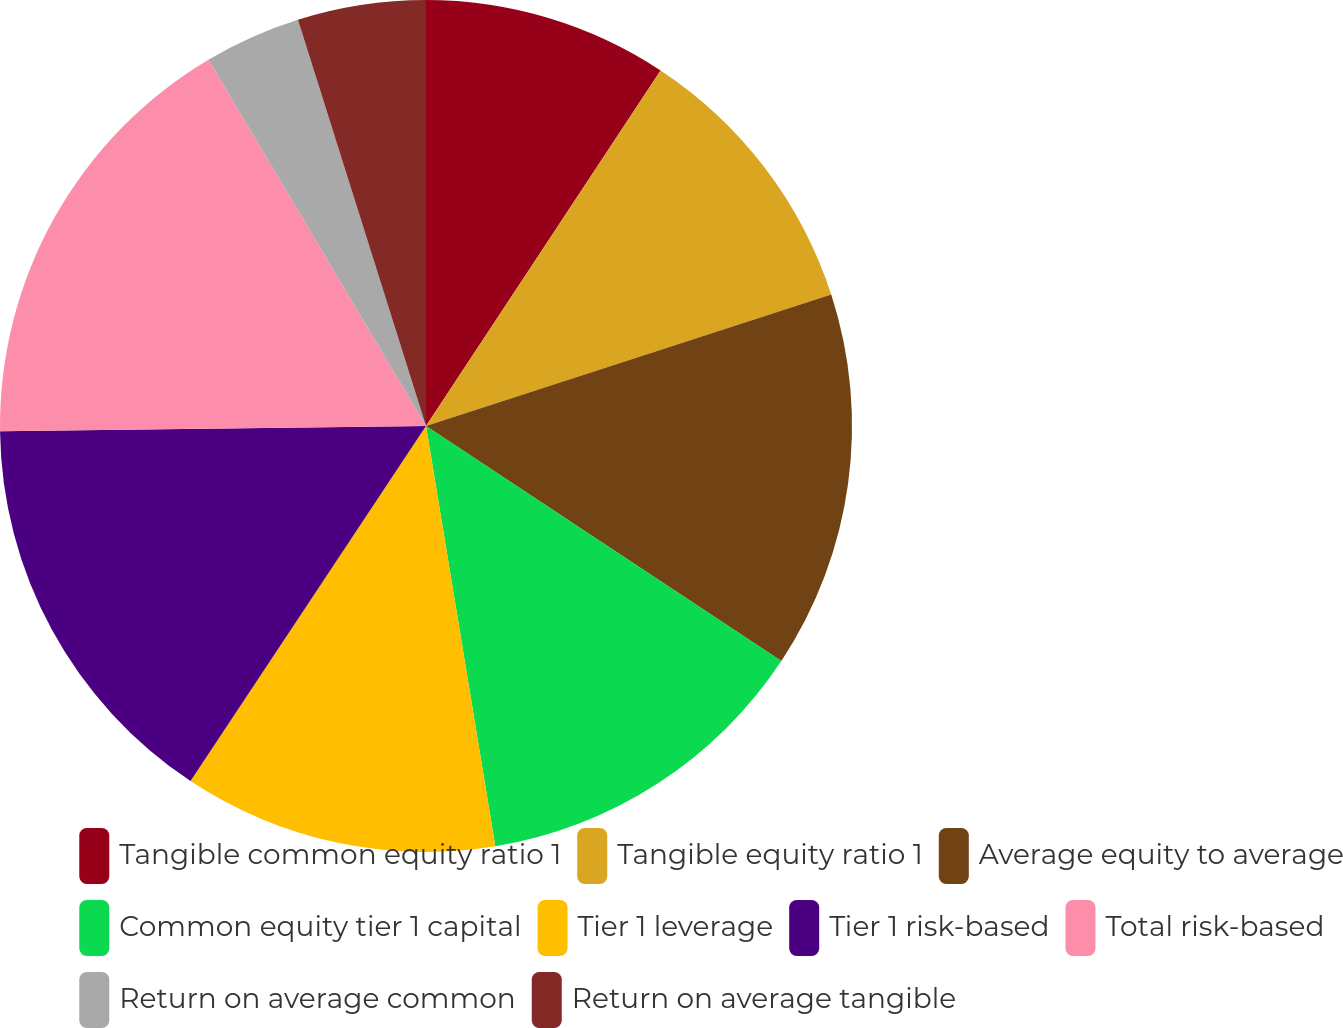Convert chart. <chart><loc_0><loc_0><loc_500><loc_500><pie_chart><fcel>Tangible common equity ratio 1<fcel>Tangible equity ratio 1<fcel>Average equity to average<fcel>Common equity tier 1 capital<fcel>Tier 1 leverage<fcel>Tier 1 risk-based<fcel>Total risk-based<fcel>Return on average common<fcel>Return on average tangible<nl><fcel>9.28%<fcel>10.73%<fcel>14.29%<fcel>13.1%<fcel>11.92%<fcel>15.48%<fcel>16.67%<fcel>3.67%<fcel>4.86%<nl></chart> 